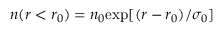<formula> <loc_0><loc_0><loc_500><loc_500>n ( r < r _ { 0 } ) = n _ { 0 } e x p [ ( r - r _ { 0 } ) / \sigma _ { 0 } ]</formula> 